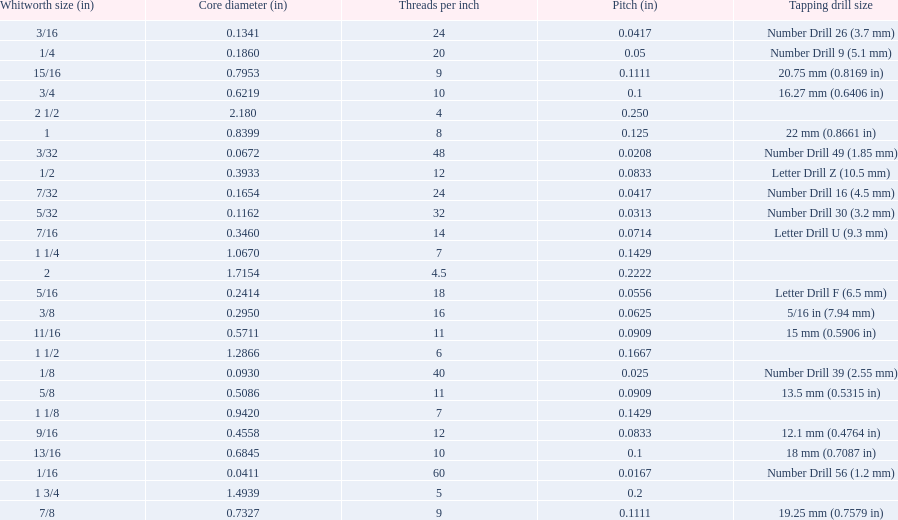What are all of the whitworth sizes? 1/16, 3/32, 1/8, 5/32, 3/16, 7/32, 1/4, 5/16, 3/8, 7/16, 1/2, 9/16, 5/8, 11/16, 3/4, 13/16, 7/8, 15/16, 1, 1 1/8, 1 1/4, 1 1/2, 1 3/4, 2, 2 1/2. How many threads per inch are in each size? 60, 48, 40, 32, 24, 24, 20, 18, 16, 14, 12, 12, 11, 11, 10, 10, 9, 9, 8, 7, 7, 6, 5, 4.5, 4. How many threads per inch are in the 3/16 size? 24. And which other size has the same number of threads? 7/32. 